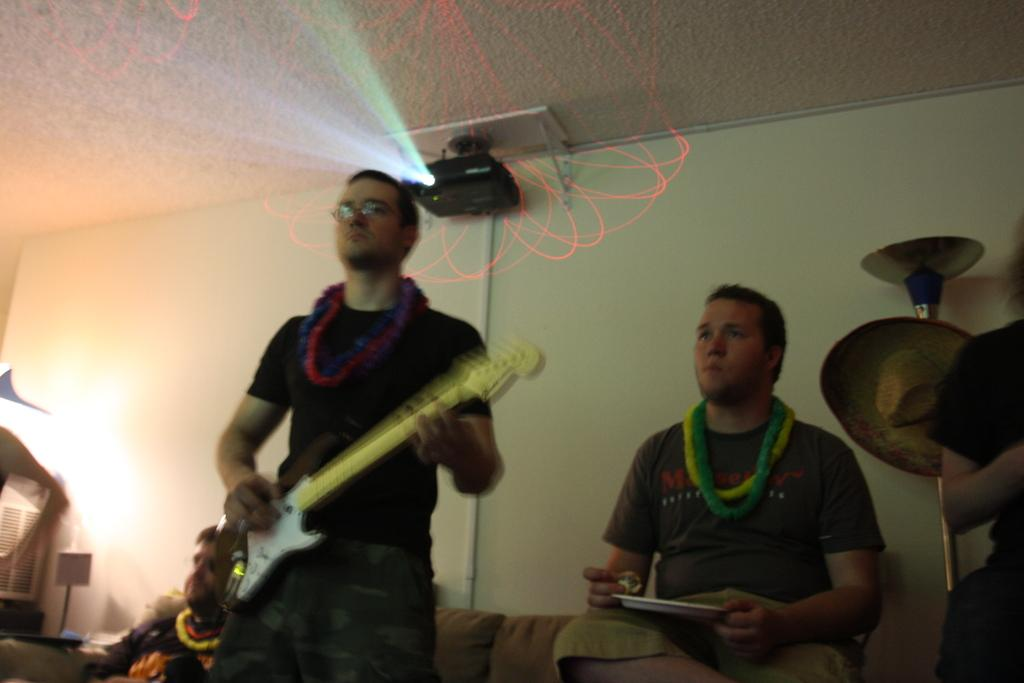How many people are in the image? There are multiple people in the image. What is one person doing in the image? One man is playing a guitar. What can be seen in the background of the image? There is a projector visible in the background. What type of insect is crawling on the guitar in the image? There is no insect present on the guitar in the image. What record is being played on the projector in the image? There is no record being played on the projector in the image; it is simply a visible object in the background. 